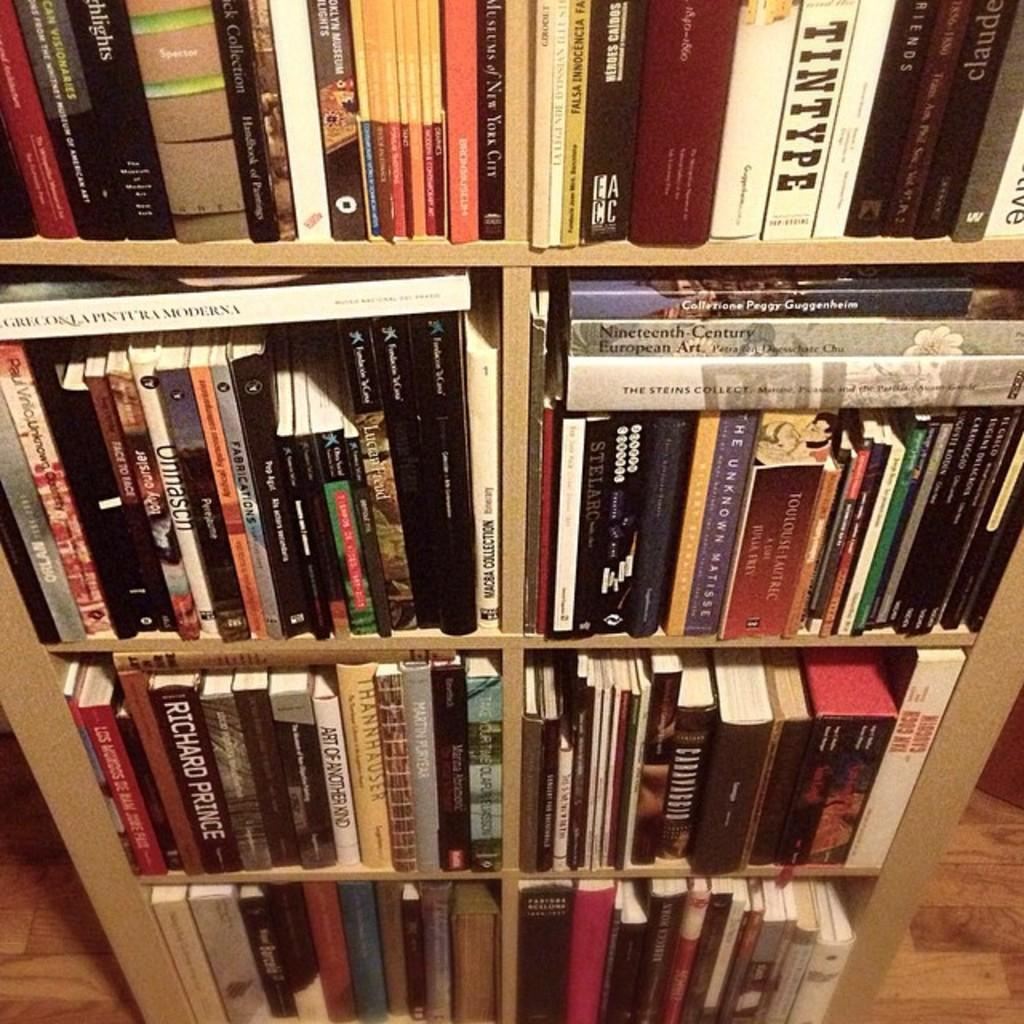<image>
Relay a brief, clear account of the picture shown. A full bookshelf with a book called Tintype on the top shelf. 